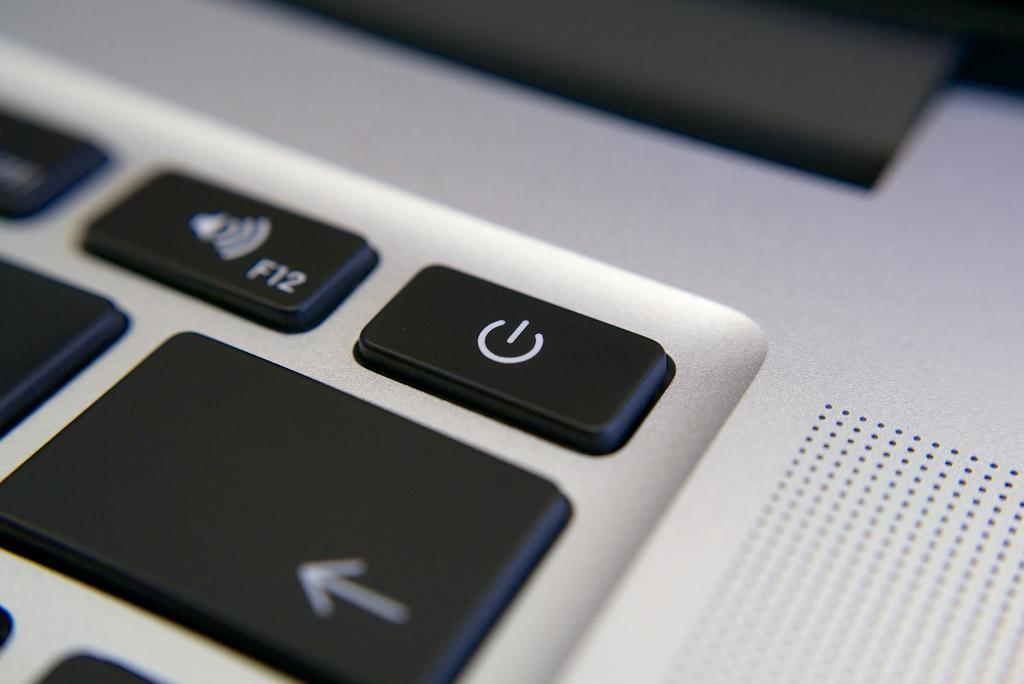<image>
Create a compact narrative representing the image presented. The F12 key is next to an arrow key on a keyboard. 